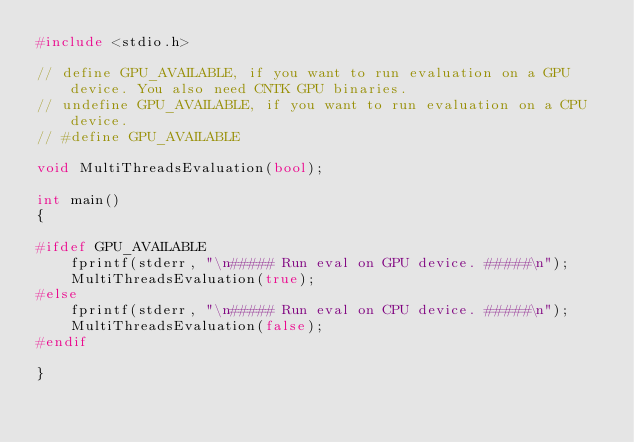<code> <loc_0><loc_0><loc_500><loc_500><_C++_>#include <stdio.h>

// define GPU_AVAILABLE, if you want to run evaluation on a GPU device. You also need CNTK GPU binaries.
// undefine GPU_AVAILABLE, if you want to run evaluation on a CPU device.
// #define GPU_AVAILABLE

void MultiThreadsEvaluation(bool);

int main()
{

#ifdef GPU_AVAILABLE
    fprintf(stderr, "\n##### Run eval on GPU device. #####\n");
    MultiThreadsEvaluation(true);
#else
    fprintf(stderr, "\n##### Run eval on CPU device. #####\n");
    MultiThreadsEvaluation(false);
#endif

}
</code> 